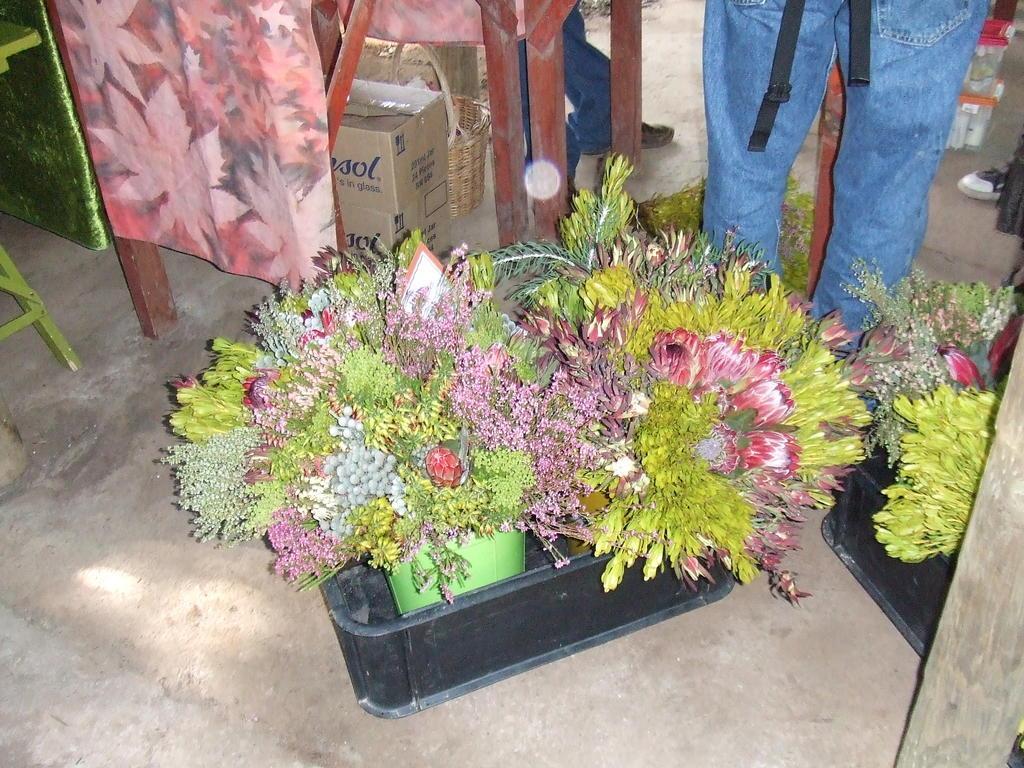In one or two sentences, can you explain what this image depicts? In this picture we can see a few flower pots on the path. We can see a basket, boxes and a few people are visible in the background. There is a table on the left side. 